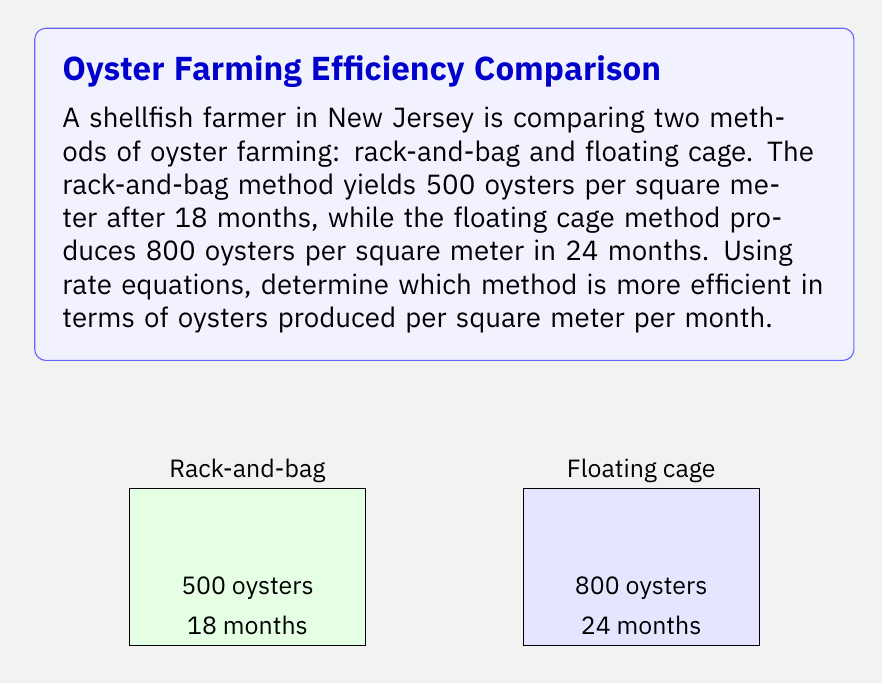Can you solve this math problem? To compare the efficiency of the two methods, we need to calculate the rate of oyster production for each method in terms of oysters per square meter per month.

1. Rack-and-bag method:
   Rate = $\frac{\text{Number of oysters}}{\text{Area} \times \text{Time}}$
   $R_1 = \frac{500 \text{ oysters}}{1 \text{ m}^2 \times 18 \text{ months}}$
   $R_1 = \frac{500}{18} \approx 27.78 \text{ oysters/m}^2\text{/month}$

2. Floating cage method:
   Rate = $\frac{\text{Number of oysters}}{\text{Area} \times \text{Time}}$
   $R_2 = \frac{800 \text{ oysters}}{1 \text{ m}^2 \times 24 \text{ months}}$
   $R_2 = \frac{800}{24} \approx 33.33 \text{ oysters/m}^2\text{/month}$

3. Compare the rates:
   $R_2 > R_1$, so the floating cage method is more efficient.

4. Calculate the difference in efficiency:
   Difference = $R_2 - R_1 = 33.33 - 27.78 = 5.55 \text{ oysters/m}^2\text{/month}$

5. Calculate the percentage increase in efficiency:
   Percentage increase = $\frac{R_2 - R_1}{R_1} \times 100\%$
   $= \frac{33.33 - 27.78}{27.78} \times 100\% \approx 20\%$
Answer: Floating cage method; 20% more efficient 